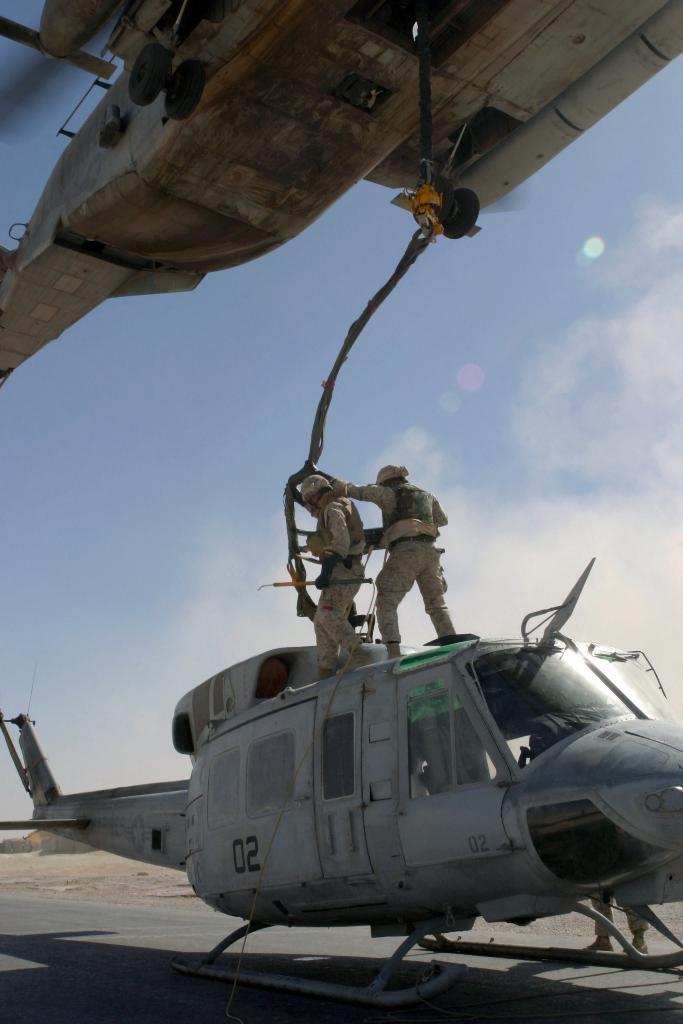<image>
Write a terse but informative summary of the picture. the word 02 is on the great helicopter 